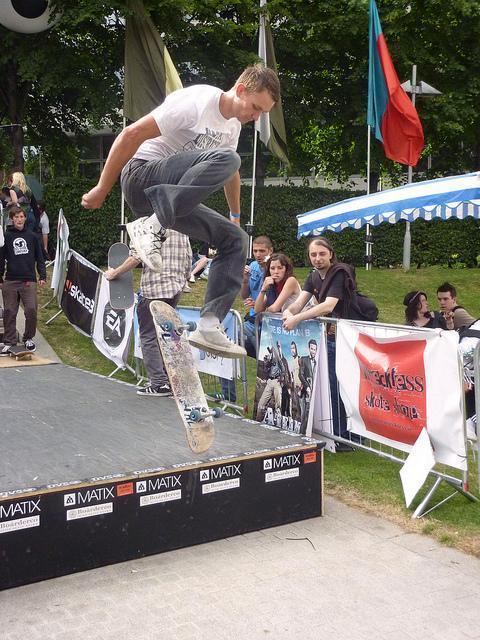How many people are in the picture?
Give a very brief answer. 4. How many cakes do you see?
Give a very brief answer. 0. 